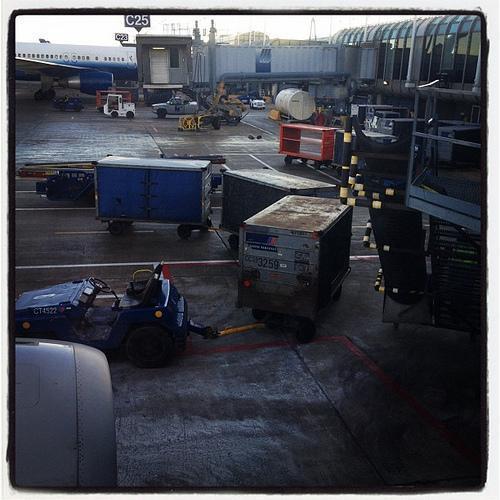How many planes are visible?
Give a very brief answer. 1. How many automobiles are in the image?
Give a very brief answer. 5. 